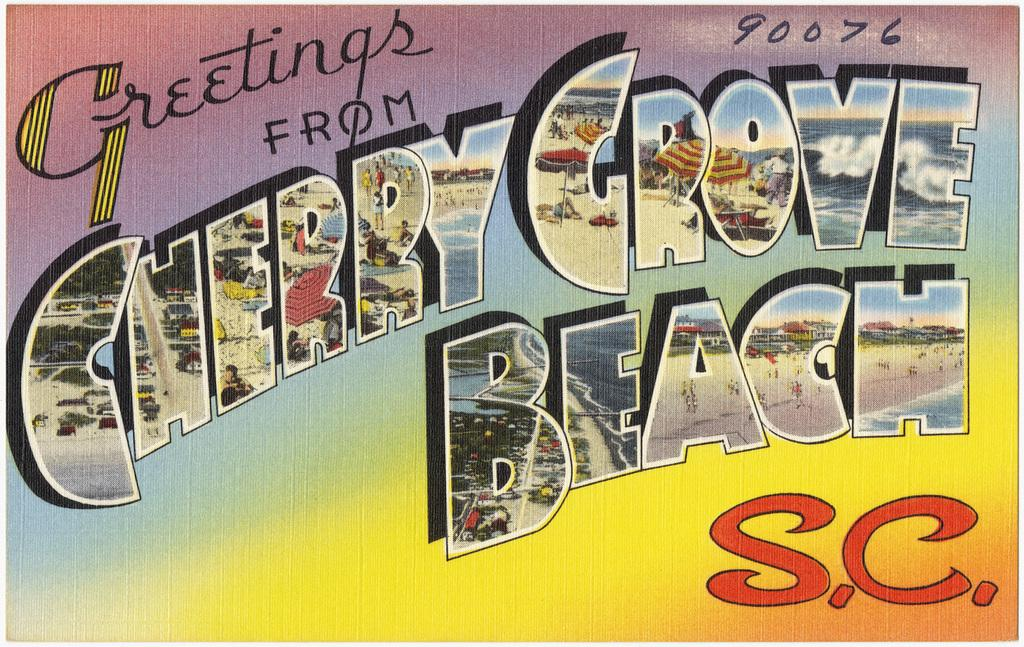Provide a one-sentence caption for the provided image. A greeting post card from Cherry Grove Beach. 